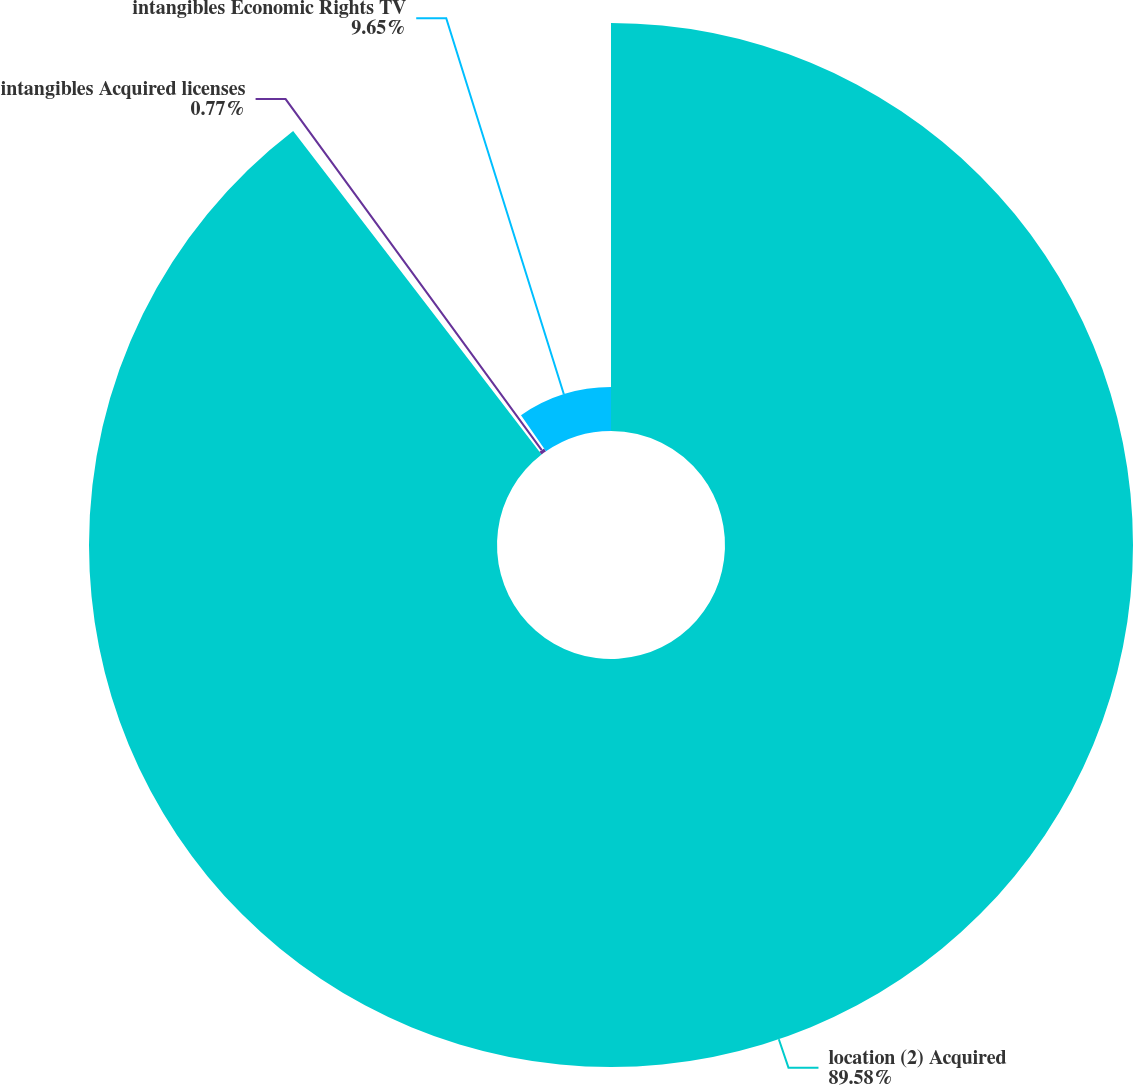Convert chart to OTSL. <chart><loc_0><loc_0><loc_500><loc_500><pie_chart><fcel>location (2) Acquired<fcel>intangibles Acquired licenses<fcel>intangibles Economic Rights TV<nl><fcel>89.59%<fcel>0.77%<fcel>9.65%<nl></chart> 